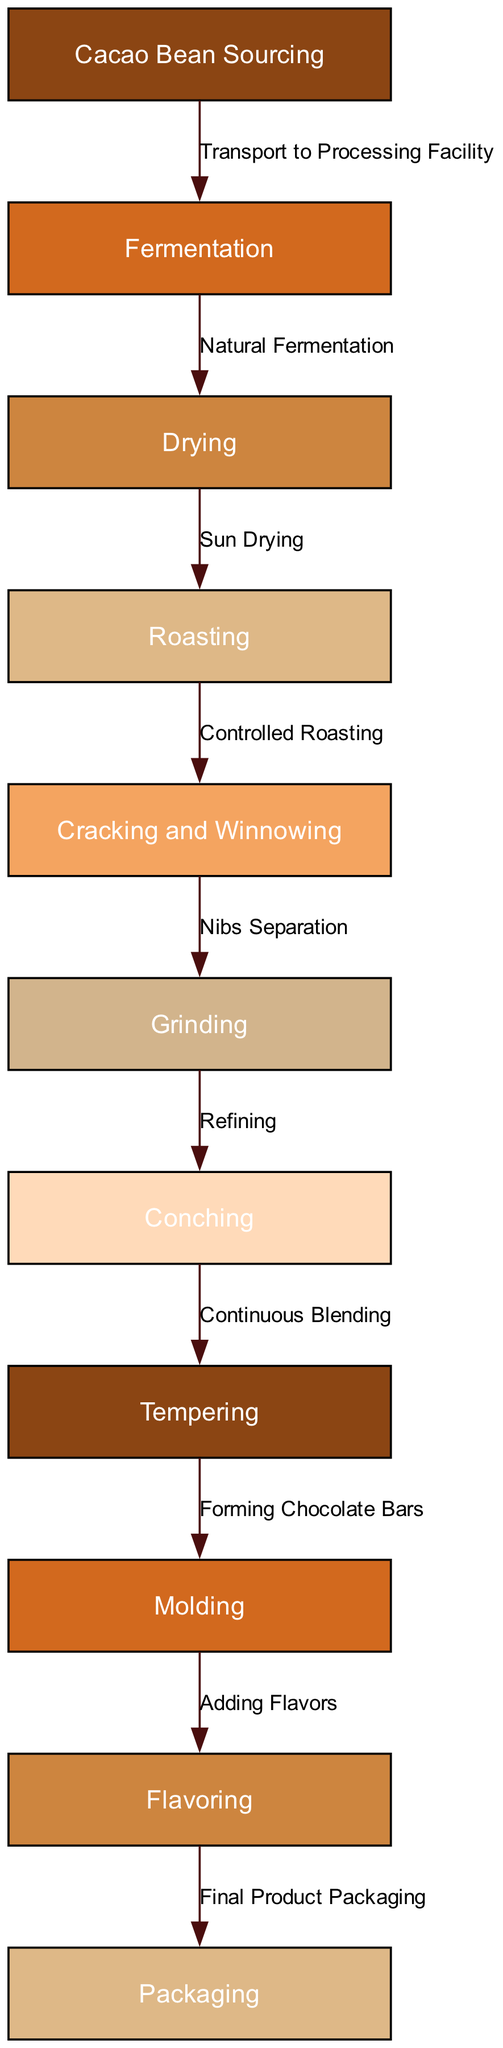How many nodes are in the diagram? The diagram contains a total of 11 nodes, as listed in the data provided, each representing a step in the chocolate production process.
Answer: 11 What is the last step before packaging? The last step before packaging is "Flavoring," as indicated by the edge that connects "Flavoring" to "Packaging."
Answer: Flavoring What is the first step in the chocolate production process? The first step in the chocolate production process is "Cacao Bean Sourcing," which is represented by the first node in the flowchart.
Answer: Cacao Bean Sourcing What process follows drying? "Roasting" is the process that follows drying in the flowchart, as indicated by the directed edge from the "Drying" node to the "Roasting" node.
Answer: Roasting How many edges are connecting the nodes? There are 10 edges in the diagram connecting the nodes, as each directed step in the chocolate production process represents one edge.
Answer: 10 What is the relationship between "Conching" and "Grinding"? The relationship is that "Conching" follows "Grinding," implying that after grinding, the mixture is refined during the conching process, as indicated by the flow direction.
Answer: Conching follows Grinding Which step involves adding flavors? The step that involves adding flavors is "Flavoring," which is directly preceded by "Molding" in the flowchart.
Answer: Flavoring What is the process used to separate nibs? The process used to separate nibs is "Cracking and Winnowing," as depicted in the diagram where it comes after "Roasting."
Answer: Cracking and Winnowing What stage in the process does "Transport to Processing Facility" represent? "Transport to Processing Facility" represents the edge connecting "Cacao Bean Sourcing" to "Fermentation," indicating the transportation step between sourcing and fermentation.
Answer: It represents transportation 